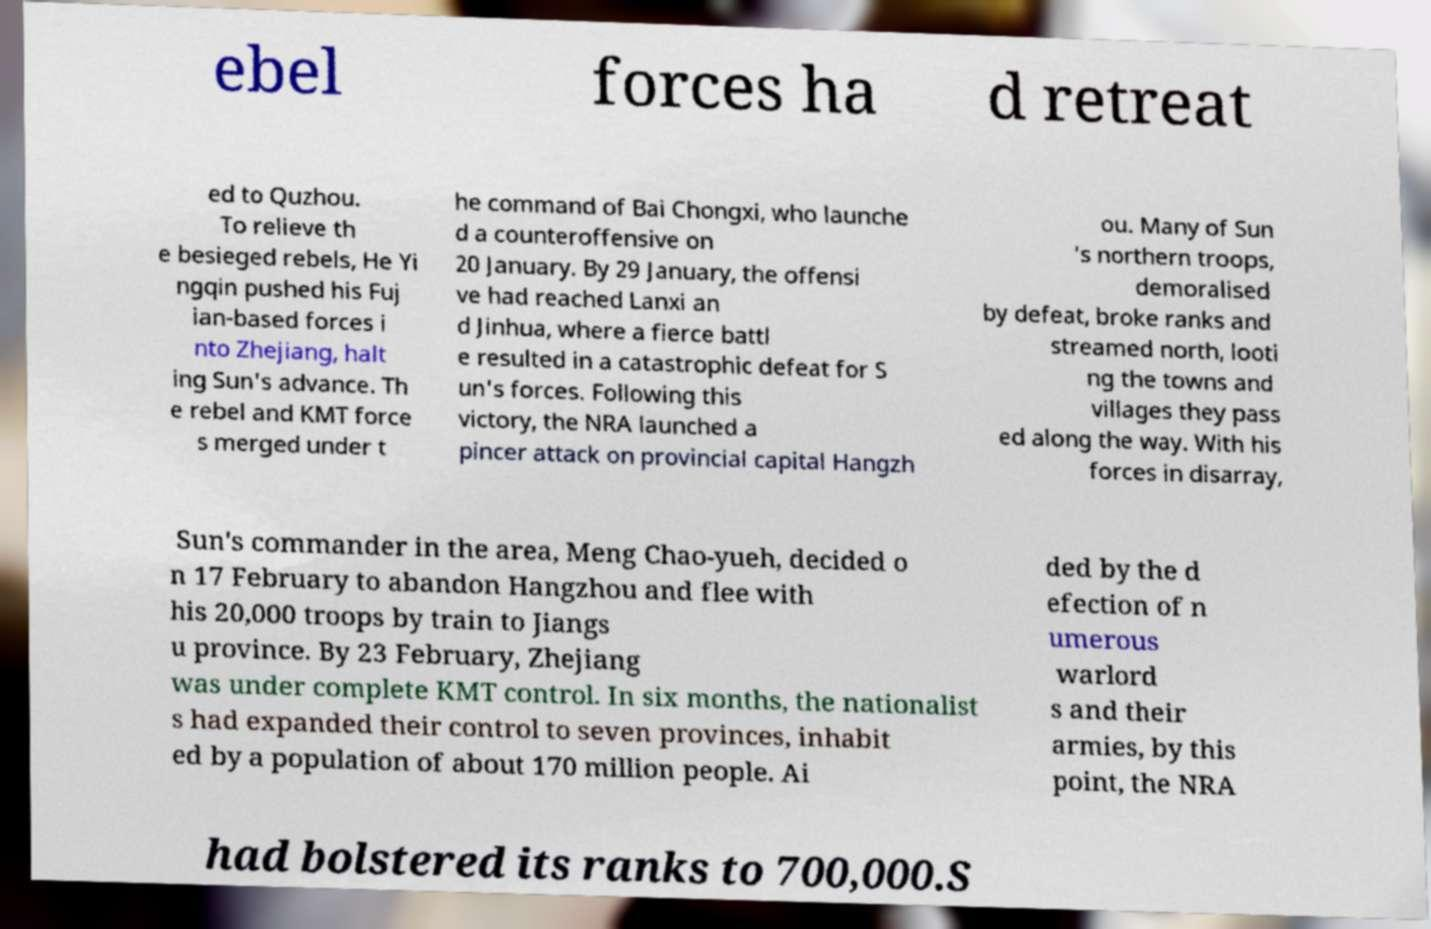Please read and relay the text visible in this image. What does it say? ebel forces ha d retreat ed to Quzhou. To relieve th e besieged rebels, He Yi ngqin pushed his Fuj ian-based forces i nto Zhejiang, halt ing Sun's advance. Th e rebel and KMT force s merged under t he command of Bai Chongxi, who launche d a counteroffensive on 20 January. By 29 January, the offensi ve had reached Lanxi an d Jinhua, where a fierce battl e resulted in a catastrophic defeat for S un's forces. Following this victory, the NRA launched a pincer attack on provincial capital Hangzh ou. Many of Sun 's northern troops, demoralised by defeat, broke ranks and streamed north, looti ng the towns and villages they pass ed along the way. With his forces in disarray, Sun's commander in the area, Meng Chao-yueh, decided o n 17 February to abandon Hangzhou and flee with his 20,000 troops by train to Jiangs u province. By 23 February, Zhejiang was under complete KMT control. In six months, the nationalist s had expanded their control to seven provinces, inhabit ed by a population of about 170 million people. Ai ded by the d efection of n umerous warlord s and their armies, by this point, the NRA had bolstered its ranks to 700,000.S 